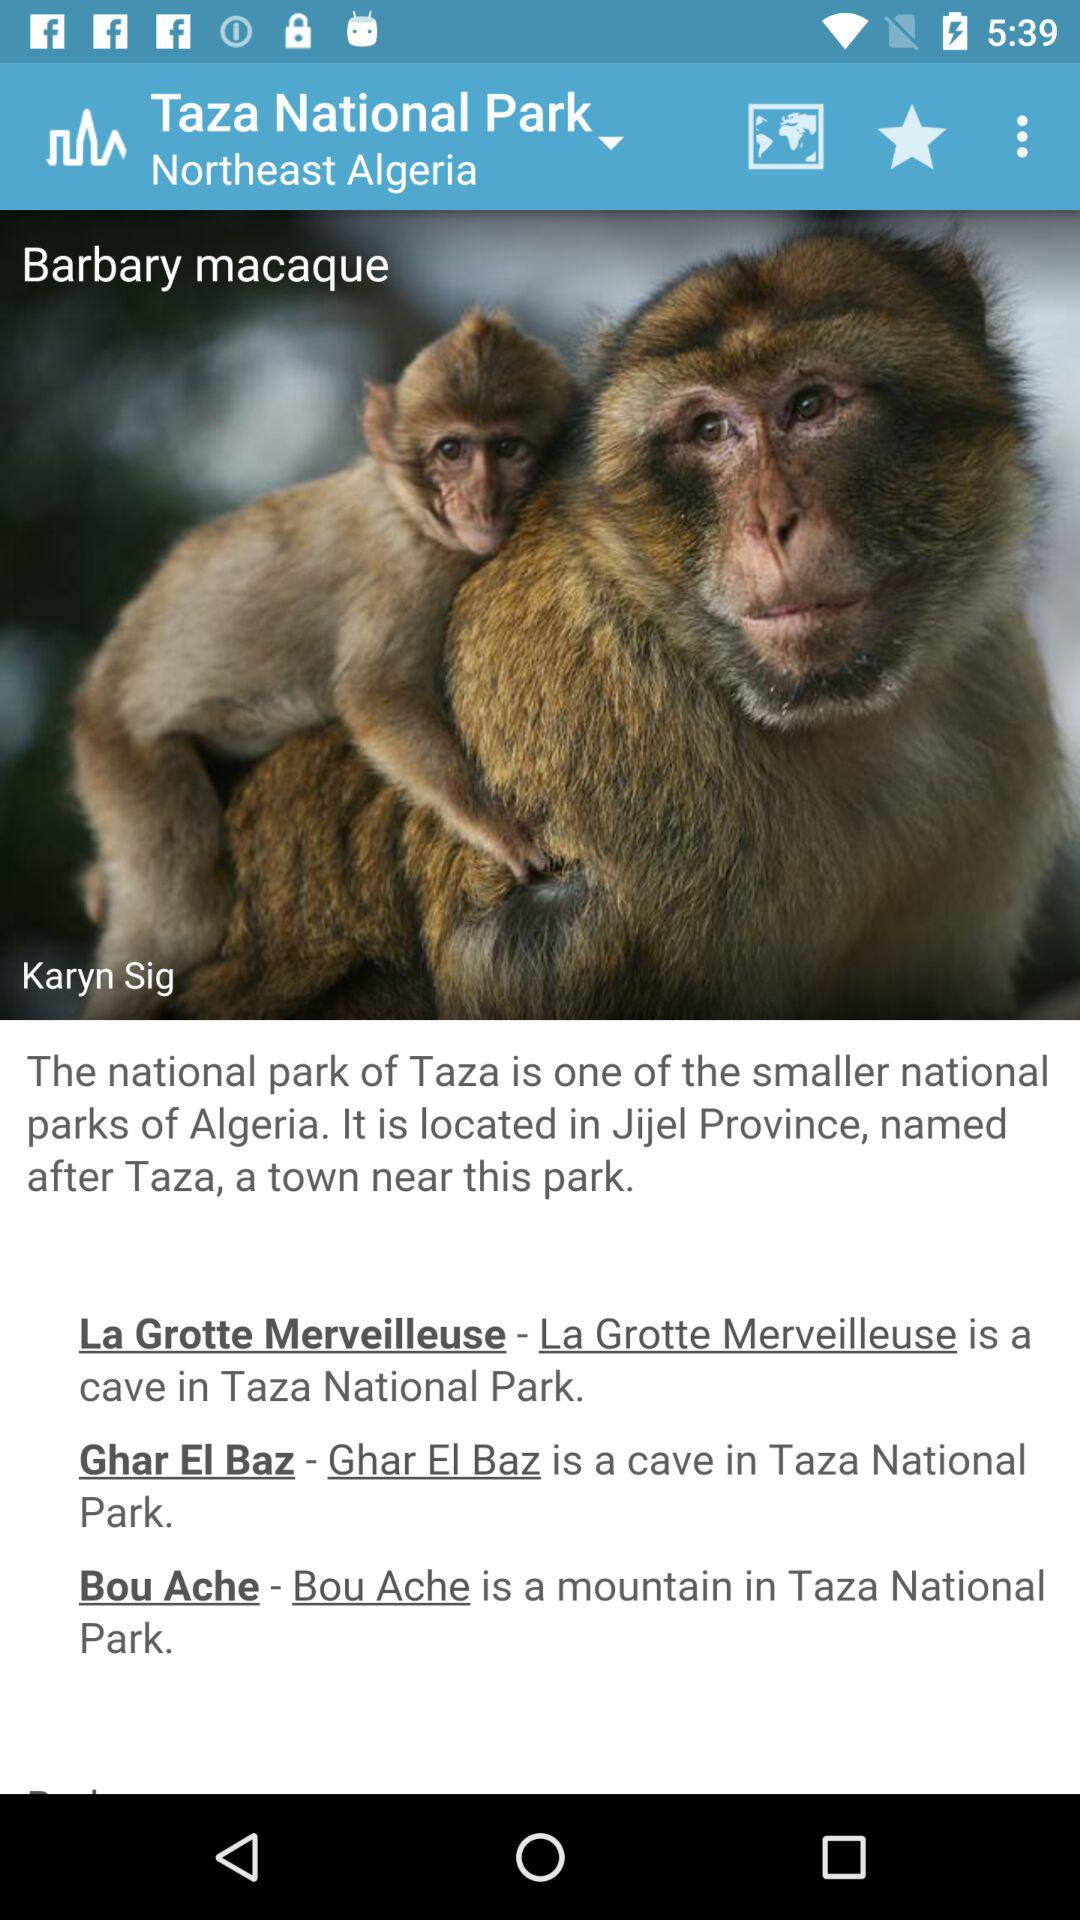What is the mountain name in "Taza National Park"? The mountain name is "Bou Ache". 